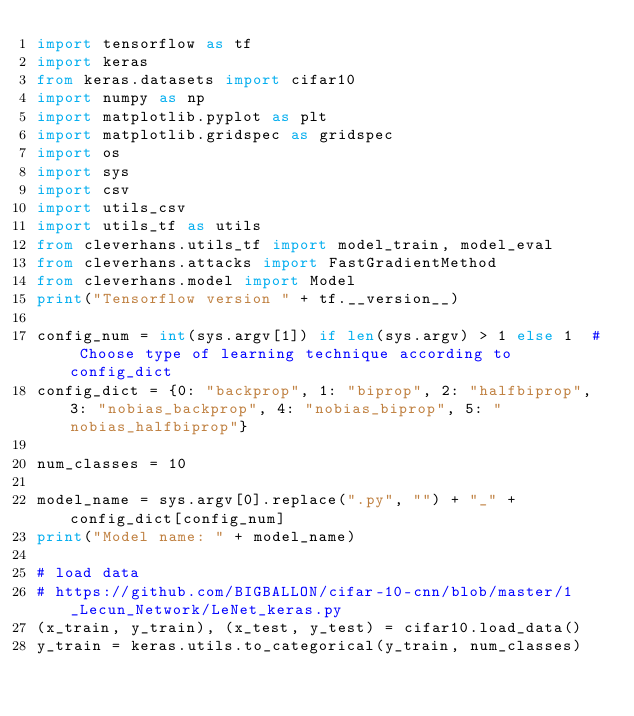<code> <loc_0><loc_0><loc_500><loc_500><_Python_>import tensorflow as tf
import keras
from keras.datasets import cifar10
import numpy as np
import matplotlib.pyplot as plt
import matplotlib.gridspec as gridspec
import os
import sys
import csv
import utils_csv
import utils_tf as utils
from cleverhans.utils_tf import model_train, model_eval
from cleverhans.attacks import FastGradientMethod
from cleverhans.model import Model
print("Tensorflow version " + tf.__version__)

config_num = int(sys.argv[1]) if len(sys.argv) > 1 else 1  # Choose type of learning technique according to config_dict
config_dict = {0: "backprop", 1: "biprop", 2: "halfbiprop", 3: "nobias_backprop", 4: "nobias_biprop", 5: "nobias_halfbiprop"}

num_classes = 10

model_name = sys.argv[0].replace(".py", "") + "_" + config_dict[config_num]
print("Model name: " + model_name)

# load data
# https://github.com/BIGBALLON/cifar-10-cnn/blob/master/1_Lecun_Network/LeNet_keras.py
(x_train, y_train), (x_test, y_test) = cifar10.load_data()
y_train = keras.utils.to_categorical(y_train, num_classes)</code> 